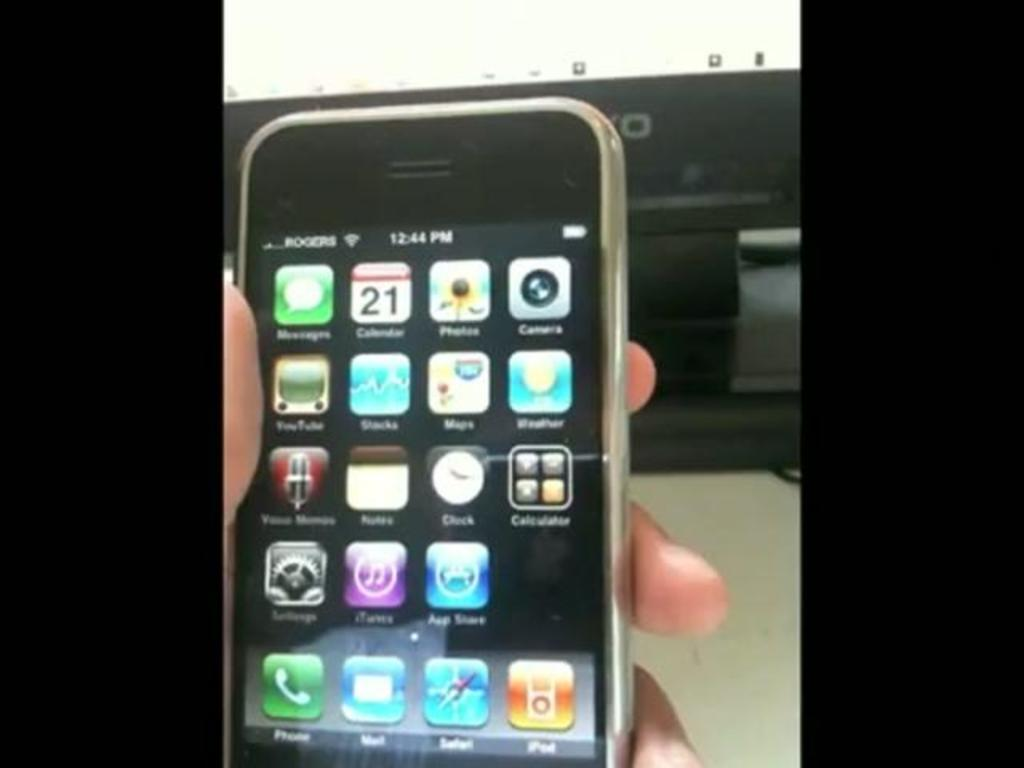<image>
Give a short and clear explanation of the subsequent image. a hand holding an iPhone  with the time 12:44. 